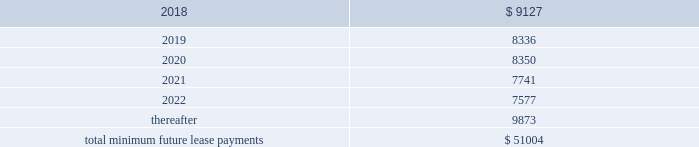As of december 31 , 2017 , the aggregate future minimum payments under non-cancelable operating leases consist of the following ( in thousands ) : years ending december 31 .
Rent expense for all operating leases amounted to $ 9.4 million , $ 8.1 million and $ 5.4 million for the years ended december 31 , 2017 , 2016 and 2015 , respectively .
Financing obligation 2014build-to-suit lease in august 2012 , we executed a lease for a building then under construction in santa clara , california to serve as our headquarters .
The lease term is 120 months and commenced in august 2013 .
Based on the terms of the lease agreement and due to our involvement in certain aspects of the construction , we were deemed the owner of the building ( for accounting purposes only ) during the construction period .
Upon completion of construction in 2013 , we concluded that we had forms of continued economic involvement in the facility , and therefore did not meet with the provisions for sale-leaseback accounting .
We continue to maintain involvement in the property post construction and lack transferability of the risks and rewards of ownership , due to our required maintenance of a $ 4.0 million letter of credit , in addition to our ability and option to sublease our portion of the leased building for fees substantially higher than our base rate .
Therefore , the lease is accounted for as a financing obligation and lease payments will be attributed to ( 1 ) a reduction of the principal financing obligation ; ( 2 ) imputed interest expense ; and ( 3 ) land lease expense , representing an imputed cost to lease the underlying land of the building .
At the conclusion of the initial lease term , we will de-recognize both the net book values of the asset and the remaining financing obligation .
As of december 31 , 2017 and 2016 , we have recorded assets of $ 53.4 million , representing the total costs of the building and improvements incurred , including the costs paid by the lessor ( the legal owner of the building ) and additional improvement costs paid by us , and a corresponding financing obligation of $ 39.6 million and $ 41.2 million , respectively .
As of december 31 , 2017 , $ 1.9 million and $ 37.7 million were recorded as short-term and long-term financing obligations , respectively .
Land lease expense under our lease financing obligation amounted to $ 1.3 million for each of the years ended december 31 , 2017 , 2016 and 2015 respectively. .
What was the ratio of the 2018 to the 2019 future minimum payments under non-cancelable operating leases? 
Rationale: the expenses in 2018 were about 10% higher than 2019
Computations: (9127 / 8336)
Answer: 1.09489. 